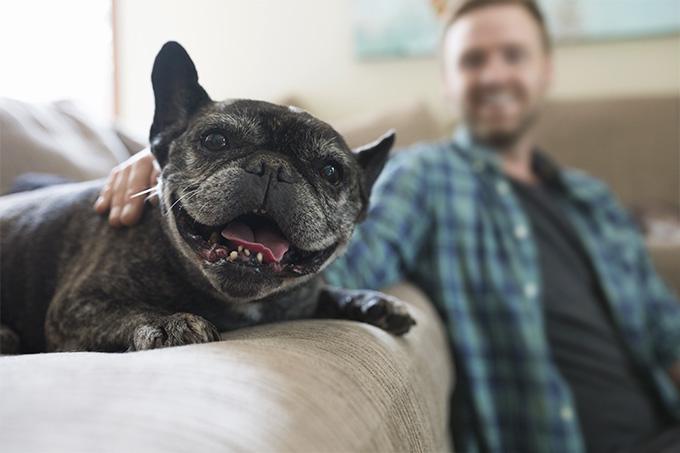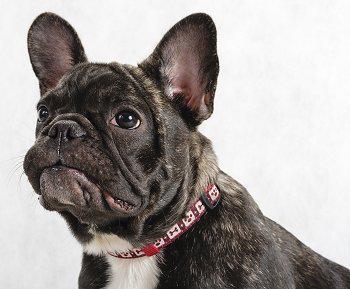The first image is the image on the left, the second image is the image on the right. Assess this claim about the two images: "At least one big-eared bulldog is standing on all fours on green grass, facing toward the camera.". Correct or not? Answer yes or no. No. The first image is the image on the left, the second image is the image on the right. Given the left and right images, does the statement "The dog in the image on the left is inside." hold true? Answer yes or no. Yes. 